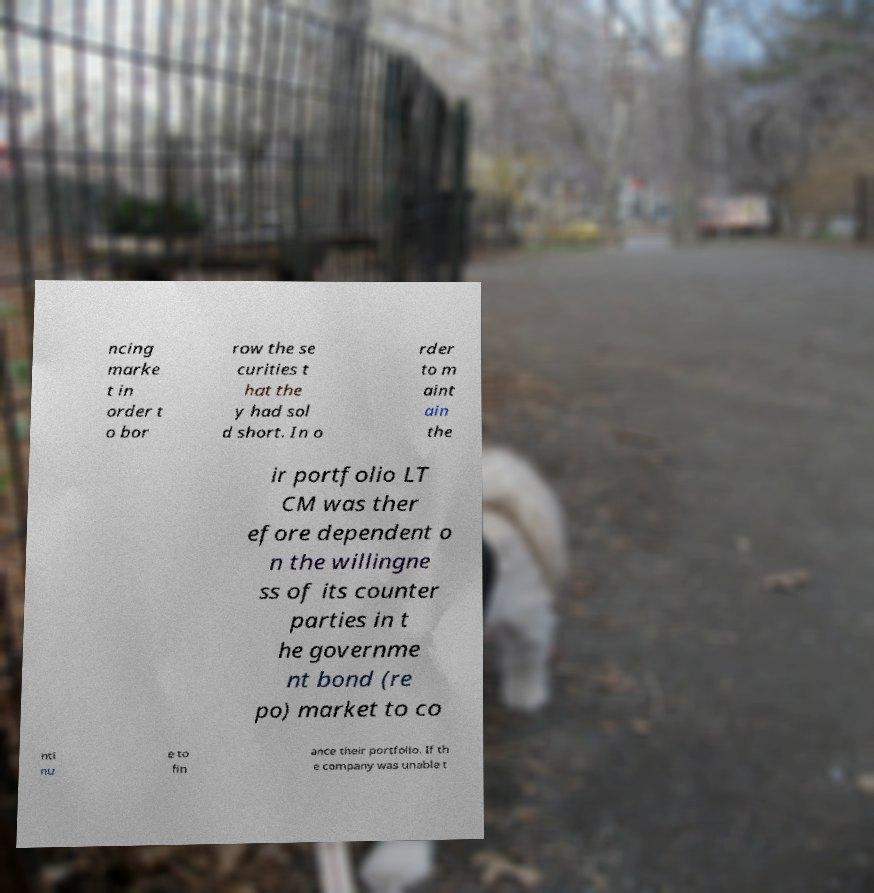Could you assist in decoding the text presented in this image and type it out clearly? ncing marke t in order t o bor row the se curities t hat the y had sol d short. In o rder to m aint ain the ir portfolio LT CM was ther efore dependent o n the willingne ss of its counter parties in t he governme nt bond (re po) market to co nti nu e to fin ance their portfolio. If th e company was unable t 